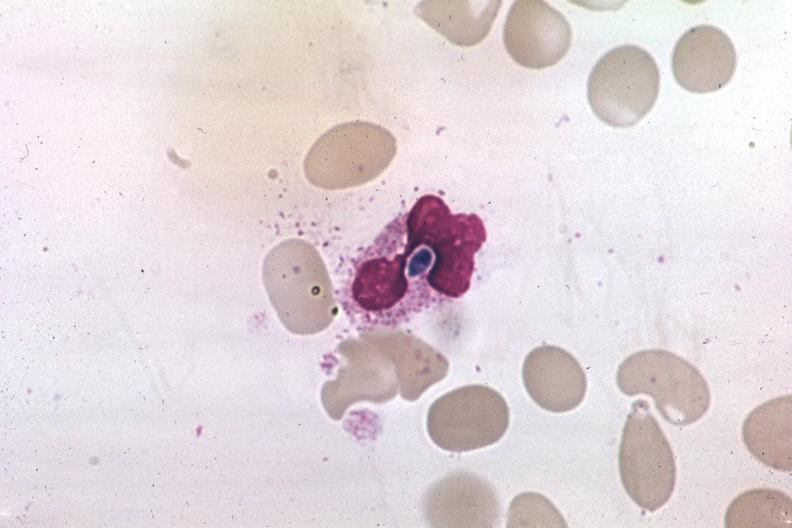what does this image show?
Answer the question using a single word or phrase. Wrights yeast form in a neutrophil 